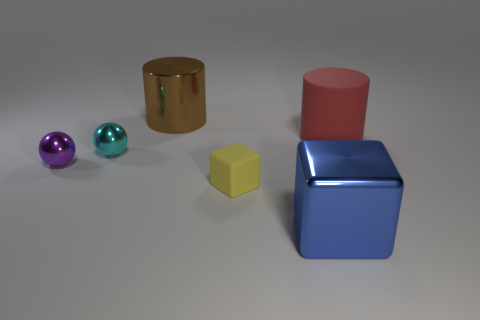Add 1 blue shiny things. How many objects exist? 7 Subtract all cylinders. How many objects are left? 4 Add 4 tiny matte objects. How many tiny matte objects exist? 5 Subtract 1 red cylinders. How many objects are left? 5 Subtract all balls. Subtract all large brown shiny cylinders. How many objects are left? 3 Add 2 big brown objects. How many big brown objects are left? 3 